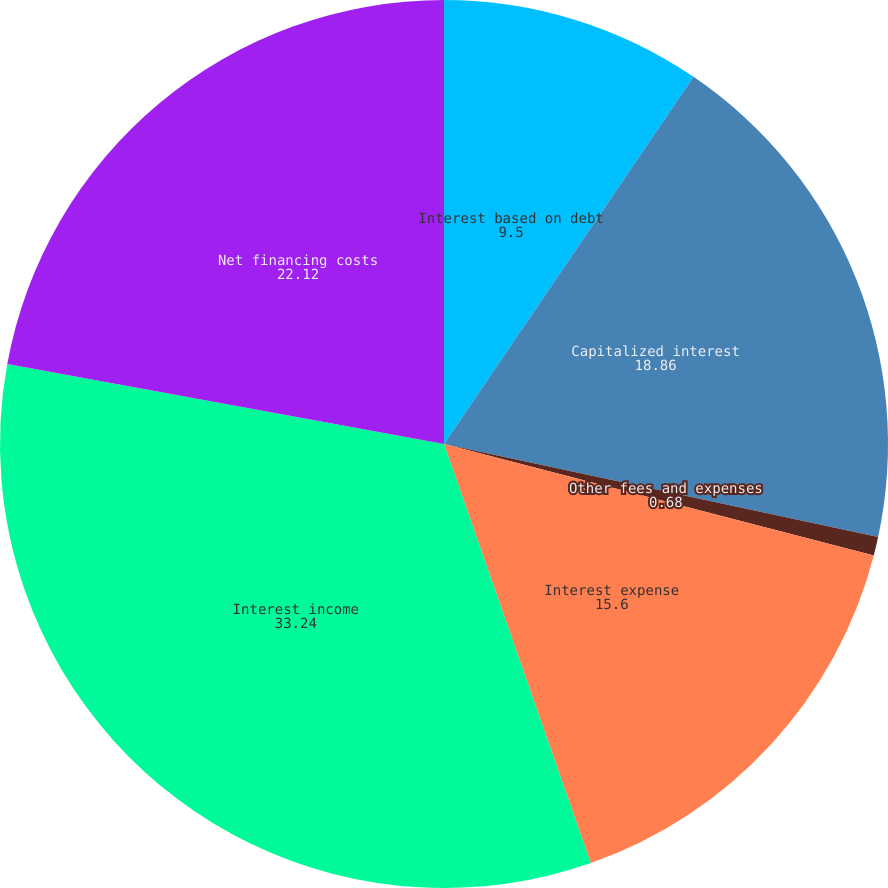Convert chart. <chart><loc_0><loc_0><loc_500><loc_500><pie_chart><fcel>Interest based on debt<fcel>Capitalized interest<fcel>Other fees and expenses<fcel>Interest expense<fcel>Interest income<fcel>Net financing costs<nl><fcel>9.5%<fcel>18.86%<fcel>0.68%<fcel>15.6%<fcel>33.24%<fcel>22.12%<nl></chart> 